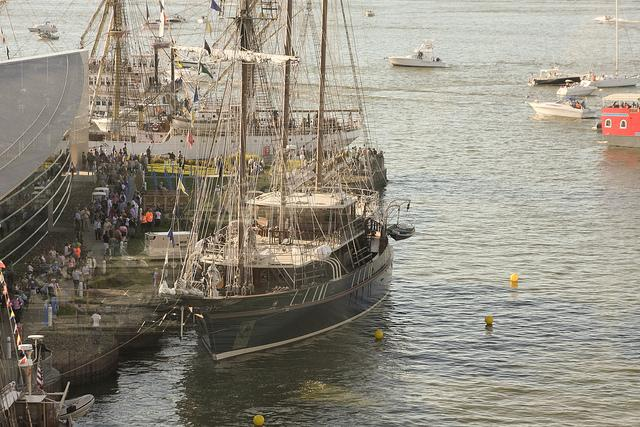What century of advancement might this boat belong to?

Choices:
A) 20th
B) 19th
C) 21st
D) 18th 18th 